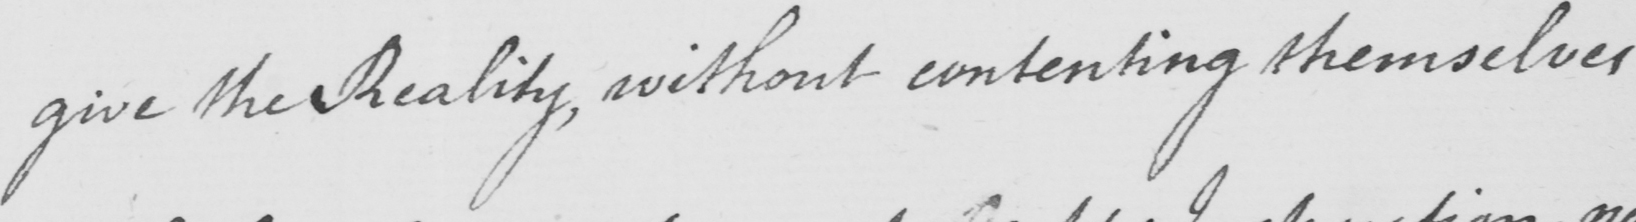What is written in this line of handwriting? give the Reality , without contenting themselves 